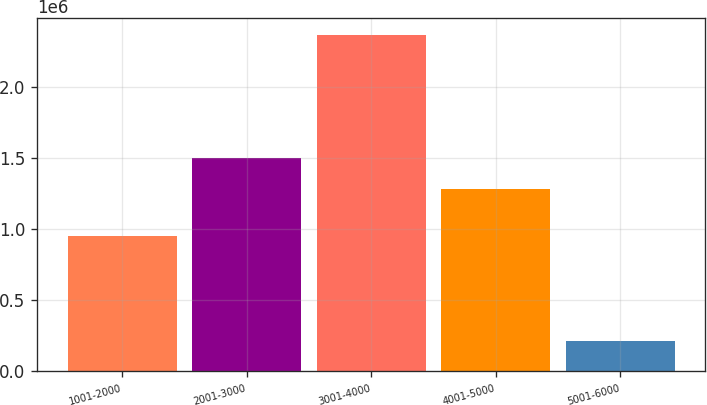Convert chart. <chart><loc_0><loc_0><loc_500><loc_500><bar_chart><fcel>1001-2000<fcel>2001-3000<fcel>3001-4000<fcel>4001-5000<fcel>5001-6000<nl><fcel>948519<fcel>1.49931e+06<fcel>2.36496e+06<fcel>1.284e+06<fcel>211875<nl></chart> 